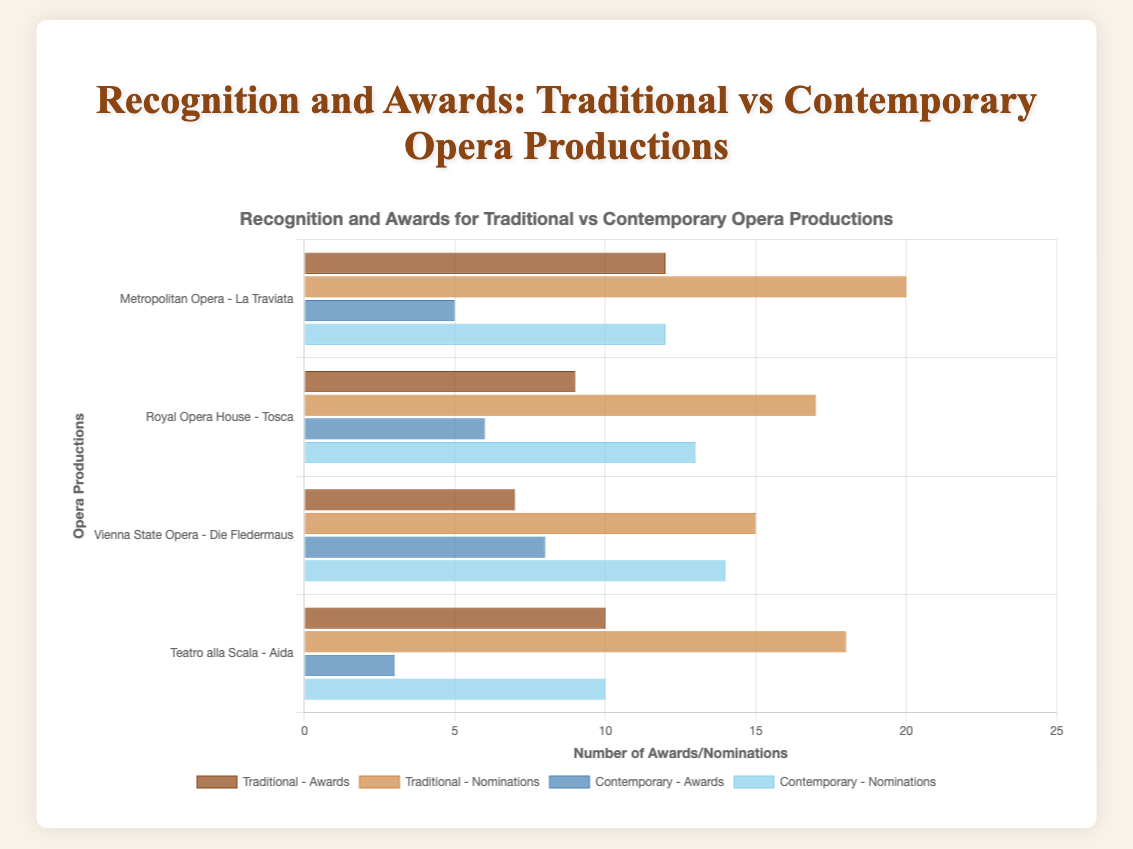What is the total number of awards received by all traditional opera productions? Sum the awarded values of all traditional opera productions: 12 (La Traviata) + 9 (Tosca) + 7 (Die Fledermaus) + 10 (Aida) = 38
Answer: 38 Which opera production received the highest number of nominations? Compare the nomination values for each opera production: La Traviata (20), Tosca (17), Die Fledermaus (15), Aida (18), Nixon in China (12), The (R)evolution of Steve Jobs (13), Breaking the Waves (14), The Passenger (10). La Traviata received the highest number of nominations.
Answer: La Traviata How do the total awards for traditional operas compare to contemporary operas? Sum the awards for traditional operas: 12 + 9 + 7 + 10 = 38. Sum the awards for contemporary operas: 5 + 6 + 8 + 3 = 22. Compare the two totals: 38 is greater than 22.
Answer: Traditional operas have more awards Which traditional opera has the least number of awards? Compare the awards for each traditional opera: La Traviata (12), Tosca (9), Die Fledermaus (7), Aida (10). Die Fledermaus has the least number of awards.
Answer: Die Fledermaus What is the average number of nominations for contemporary opera productions? Sum the nominations for all contemporary operas: 12 + 13 + 14 + 10 = 49. Divide by the number of productions: 49 / 4 = 12.25
Answer: 12.25 Compare the nominations of "Teatro alla Scala - Aida" and "Opera Philadelphia - Breaking the Waves." Which one received more nominations? Look at the nomination values: Aida (18) and Breaking the Waves (14). Aida has more nominations.
Answer: Aida Which category, traditional or contemporary, has the highest variance in the number of awards? Calculate the variance for each category:
Traditional: ( (12-9.5)^2 + (9-9.5)^2 + (7-9.5)^2 + (10-9.5)^2 ) / 4 = 4.75
Contemporary: ( (5-5.5)^2 + (6-5.5)^2 + (8-5.5)^2 + (3-5.5)^2 ) / 4 = 4.25
Traditional opera has a higher variance.
Answer: Traditional opera Which visual attribute indicates awards for contemporary operas? Identify the color used for awards in contemporary operas in the chart. Awards bars are blue for contemporary operas.
Answer: Blue bars How many more awards does "Metropolitan Opera - La Traviata" have compared to "Houston Grand Opera - The Passenger"? Subtract the awards of The Passenger from La Traviata: 12 - 3 = 9
Answer: 9 What is the ratio of nominations to awards for "Santa Fe Opera - The (R)evolution of Steve Jobs"? Divide the nominations by awards for The (R)evolution of Steve Jobs: 13 / 6 ≈ 2.17
Answer: 2.17 